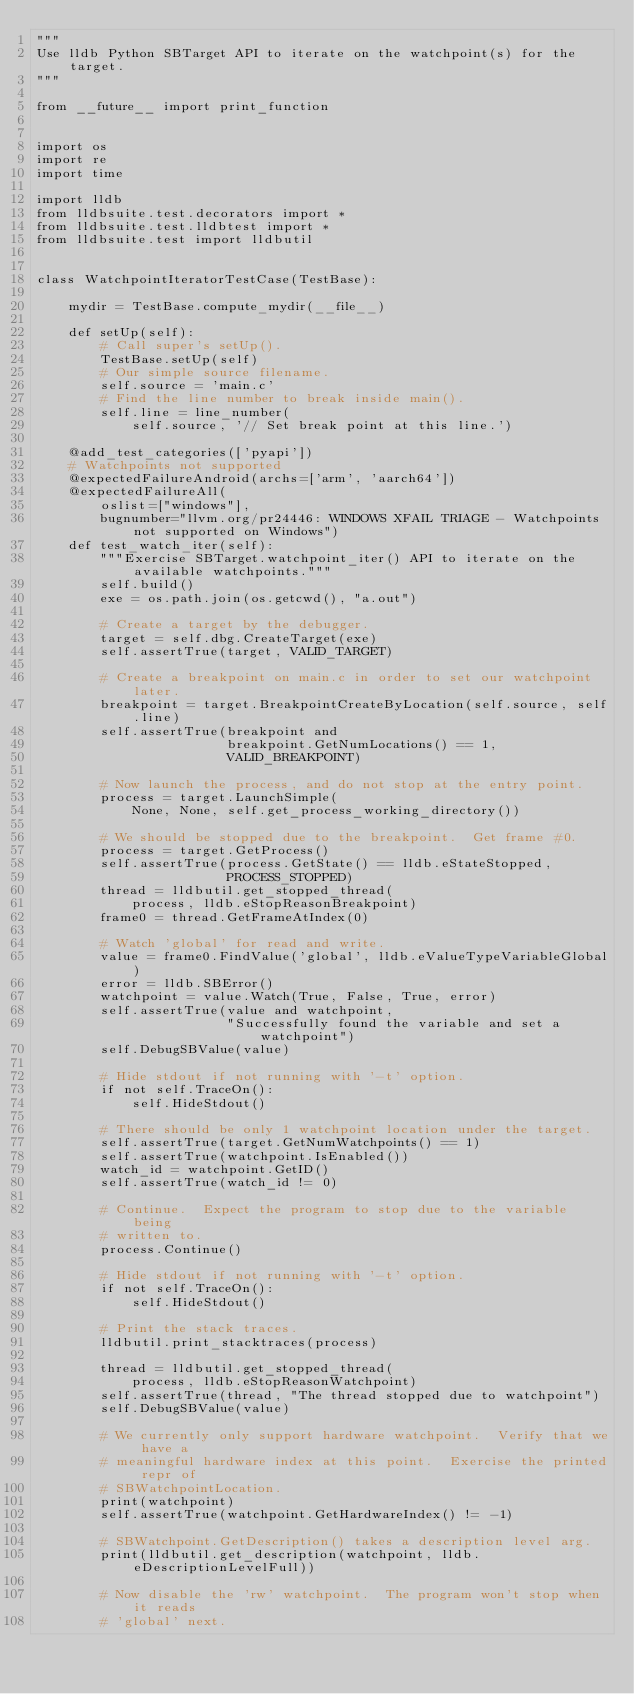Convert code to text. <code><loc_0><loc_0><loc_500><loc_500><_Python_>"""
Use lldb Python SBTarget API to iterate on the watchpoint(s) for the target.
"""

from __future__ import print_function


import os
import re
import time

import lldb
from lldbsuite.test.decorators import *
from lldbsuite.test.lldbtest import *
from lldbsuite.test import lldbutil


class WatchpointIteratorTestCase(TestBase):

    mydir = TestBase.compute_mydir(__file__)

    def setUp(self):
        # Call super's setUp().
        TestBase.setUp(self)
        # Our simple source filename.
        self.source = 'main.c'
        # Find the line number to break inside main().
        self.line = line_number(
            self.source, '// Set break point at this line.')

    @add_test_categories(['pyapi'])
    # Watchpoints not supported
    @expectedFailureAndroid(archs=['arm', 'aarch64'])
    @expectedFailureAll(
        oslist=["windows"],
        bugnumber="llvm.org/pr24446: WINDOWS XFAIL TRIAGE - Watchpoints not supported on Windows")
    def test_watch_iter(self):
        """Exercise SBTarget.watchpoint_iter() API to iterate on the available watchpoints."""
        self.build()
        exe = os.path.join(os.getcwd(), "a.out")

        # Create a target by the debugger.
        target = self.dbg.CreateTarget(exe)
        self.assertTrue(target, VALID_TARGET)

        # Create a breakpoint on main.c in order to set our watchpoint later.
        breakpoint = target.BreakpointCreateByLocation(self.source, self.line)
        self.assertTrue(breakpoint and
                        breakpoint.GetNumLocations() == 1,
                        VALID_BREAKPOINT)

        # Now launch the process, and do not stop at the entry point.
        process = target.LaunchSimple(
            None, None, self.get_process_working_directory())

        # We should be stopped due to the breakpoint.  Get frame #0.
        process = target.GetProcess()
        self.assertTrue(process.GetState() == lldb.eStateStopped,
                        PROCESS_STOPPED)
        thread = lldbutil.get_stopped_thread(
            process, lldb.eStopReasonBreakpoint)
        frame0 = thread.GetFrameAtIndex(0)

        # Watch 'global' for read and write.
        value = frame0.FindValue('global', lldb.eValueTypeVariableGlobal)
        error = lldb.SBError()
        watchpoint = value.Watch(True, False, True, error)
        self.assertTrue(value and watchpoint,
                        "Successfully found the variable and set a watchpoint")
        self.DebugSBValue(value)

        # Hide stdout if not running with '-t' option.
        if not self.TraceOn():
            self.HideStdout()

        # There should be only 1 watchpoint location under the target.
        self.assertTrue(target.GetNumWatchpoints() == 1)
        self.assertTrue(watchpoint.IsEnabled())
        watch_id = watchpoint.GetID()
        self.assertTrue(watch_id != 0)

        # Continue.  Expect the program to stop due to the variable being
        # written to.
        process.Continue()

        # Hide stdout if not running with '-t' option.
        if not self.TraceOn():
            self.HideStdout()

        # Print the stack traces.
        lldbutil.print_stacktraces(process)

        thread = lldbutil.get_stopped_thread(
            process, lldb.eStopReasonWatchpoint)
        self.assertTrue(thread, "The thread stopped due to watchpoint")
        self.DebugSBValue(value)

        # We currently only support hardware watchpoint.  Verify that we have a
        # meaningful hardware index at this point.  Exercise the printed repr of
        # SBWatchpointLocation.
        print(watchpoint)
        self.assertTrue(watchpoint.GetHardwareIndex() != -1)

        # SBWatchpoint.GetDescription() takes a description level arg.
        print(lldbutil.get_description(watchpoint, lldb.eDescriptionLevelFull))

        # Now disable the 'rw' watchpoint.  The program won't stop when it reads
        # 'global' next.</code> 